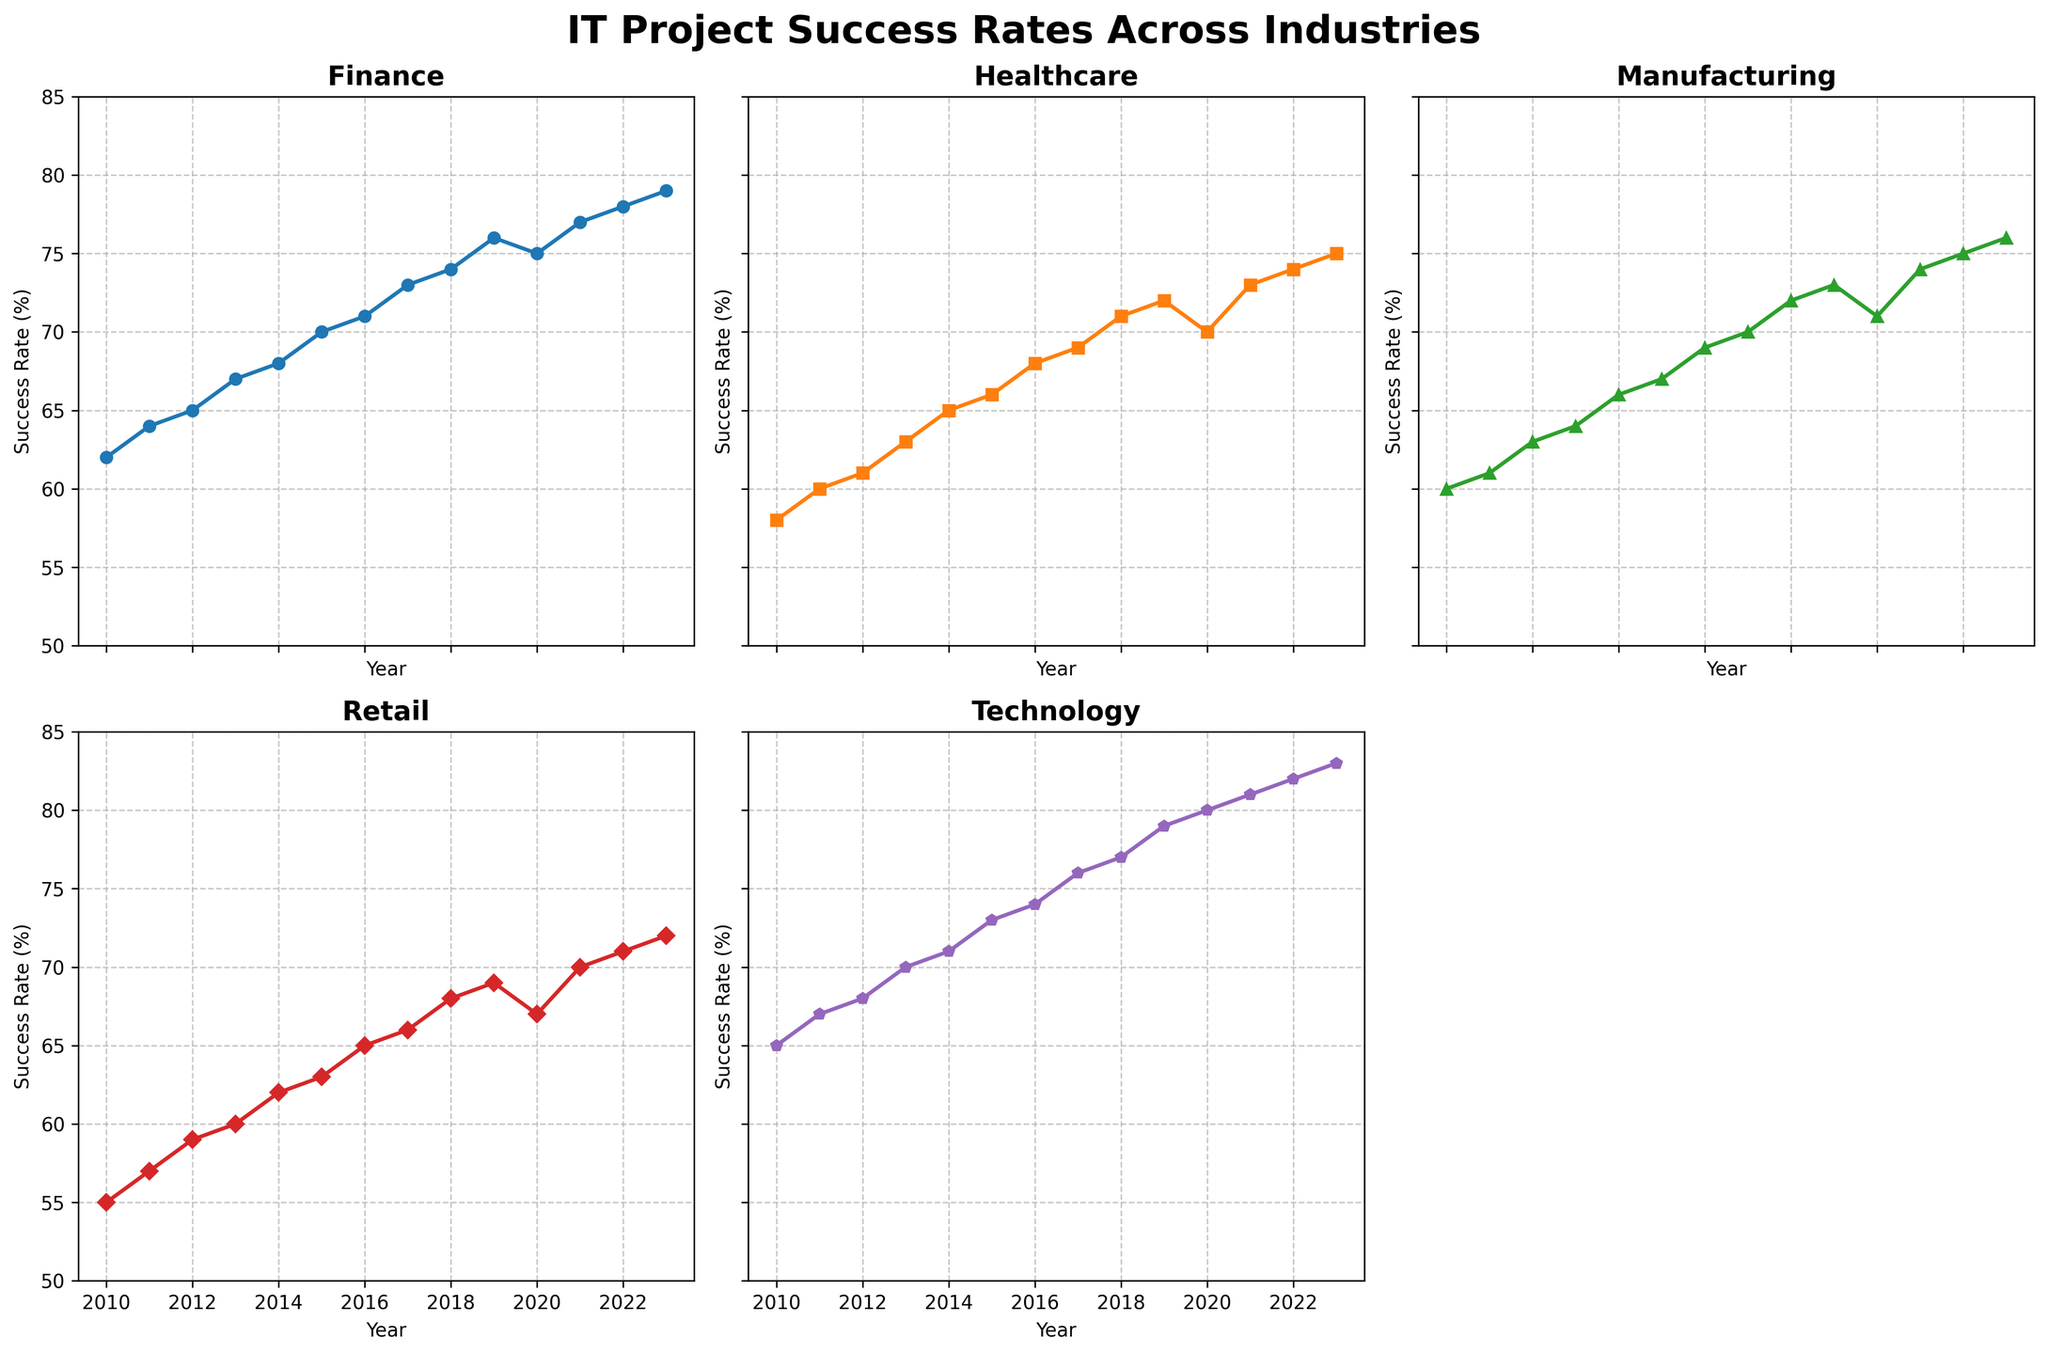What industry showed the highest success rate in 2023? The success rates for 2023 can be visually assessed by looking at the endpoints of each line. The highest endpoint corresponds to the Technology industry.
Answer: Technology Which industry had the lowest average success rate across all years? To determine the industry with the lowest average success rate, we calculate the average for each industry and identify the lowest one. The visual can help by showing the general trend and relatively lower line. Retail consistently appears to have lower success rates.
Answer: Retail How much did the success rate for Healthcare increase from 2010 to 2023? Subtract the success rate for Healthcare in 2010 from that in 2023: 75 - 58 = 17.
Answer: 17% By how much did Manufacturing's success rate exceed Retail's in 2019? Subtract Retail's success rate from Manufacturing's success rate in 2019: 73 - 69 = 4.
Answer: 4% What is the average success rate for the Technology industry over the observed years? Adding up Technology's yearly success rates (65+67+68+70+71+73+74+76+77+79+80+81+82+83) and dividing by the number of years (14): (65+67+68+70+71+73+74+76+77+79+80+81+82+83) / 14 = 74.
Answer: 74 Which industry saw the most consistent growth in success rates from 2010 to 2023? Assessing the lines, Technology consistently rises each year with a relatively steady slope.
Answer: Technology What year did Healthcare surpass a 70% success rate for the first time? By observing the points on Healthcare's line, it surpassed 70% in 2018.
Answer: 2018 Which two industries had the closest success rates in 2020? By comparing the end points for the year 2020, Finance and Healthcare both had close success rates at 75% and 70%, respectively, the smallest difference when compared to other industries.
Answer: Finance and Healthcare Between 2015 and 2020, which industry showed the highest overall growth? Subtract the 2015 success rate from the 2020 success rate for each industry. Technology had the highest growth: 80 - 73 = 7.
Answer: Technology What visual feature stands out for the Finance industry? The Finance industry consistently shows an upward trend with minimal fluctuations, visually represented by a steadily rising line.
Answer: Steady upward trend 